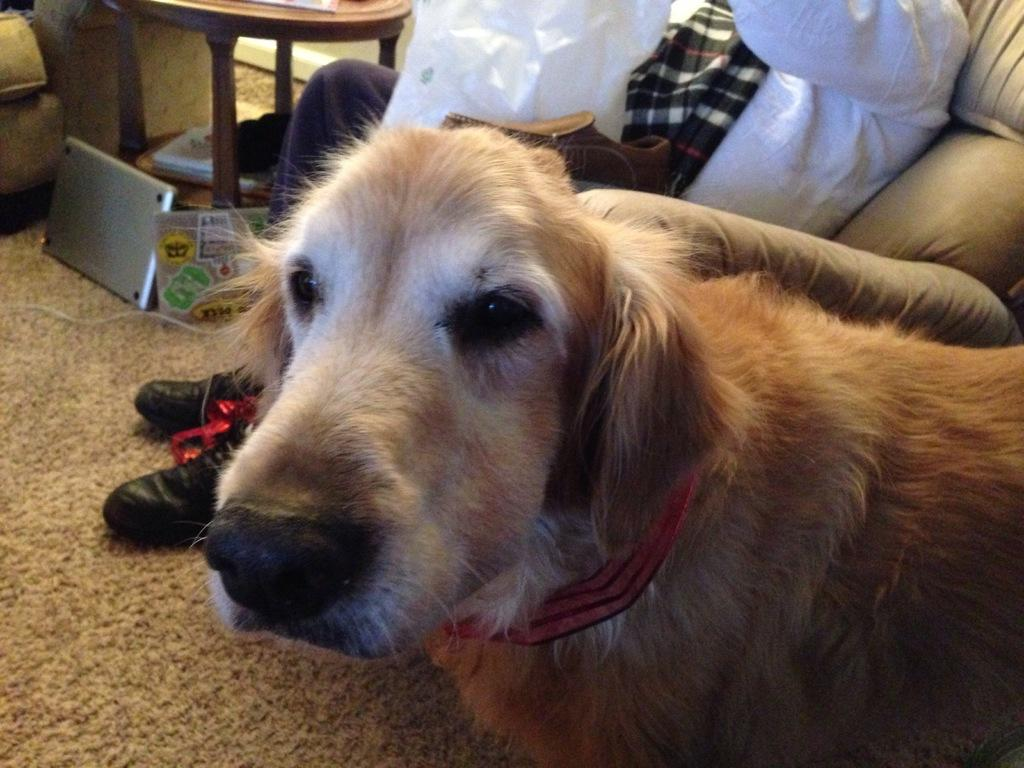What is the main subject in the foreground of the image? There is a dog in the foreground of the image. What can be seen in the background of the image? There is a person, a laptop, a stool, and other objects in the background of the image. Can you describe the person in the background? The person is not described in the provided facts, so we cannot provide any details about them. What is the price of the laptop in the image? The price of the laptop is not mentioned in the provided facts, so we cannot provide any information about it. Can you describe the secretary in the image? There is no mention of a secretary in the provided facts, so we cannot provide any information about them. 